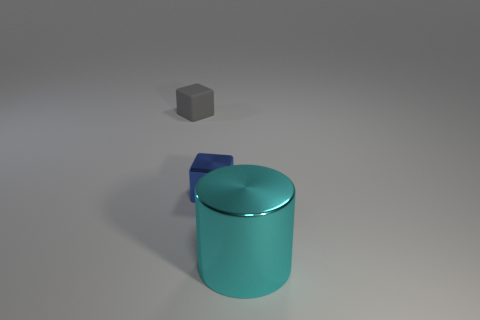Add 1 tiny cyan matte cylinders. How many objects exist? 4 Subtract all blocks. How many objects are left? 1 Subtract all rubber blocks. Subtract all rubber cubes. How many objects are left? 1 Add 3 cyan cylinders. How many cyan cylinders are left? 4 Add 2 tiny things. How many tiny things exist? 4 Subtract 0 yellow cubes. How many objects are left? 3 